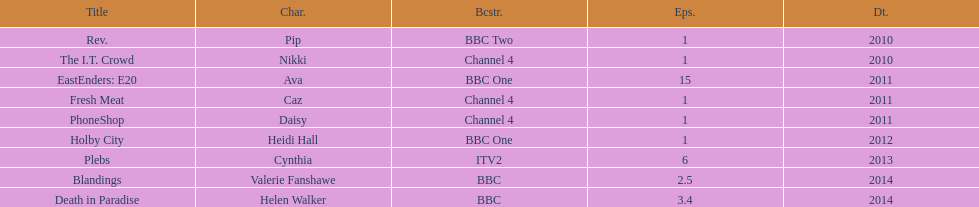Which broadcaster hosted 3 titles but they had only 1 episode? Channel 4. 